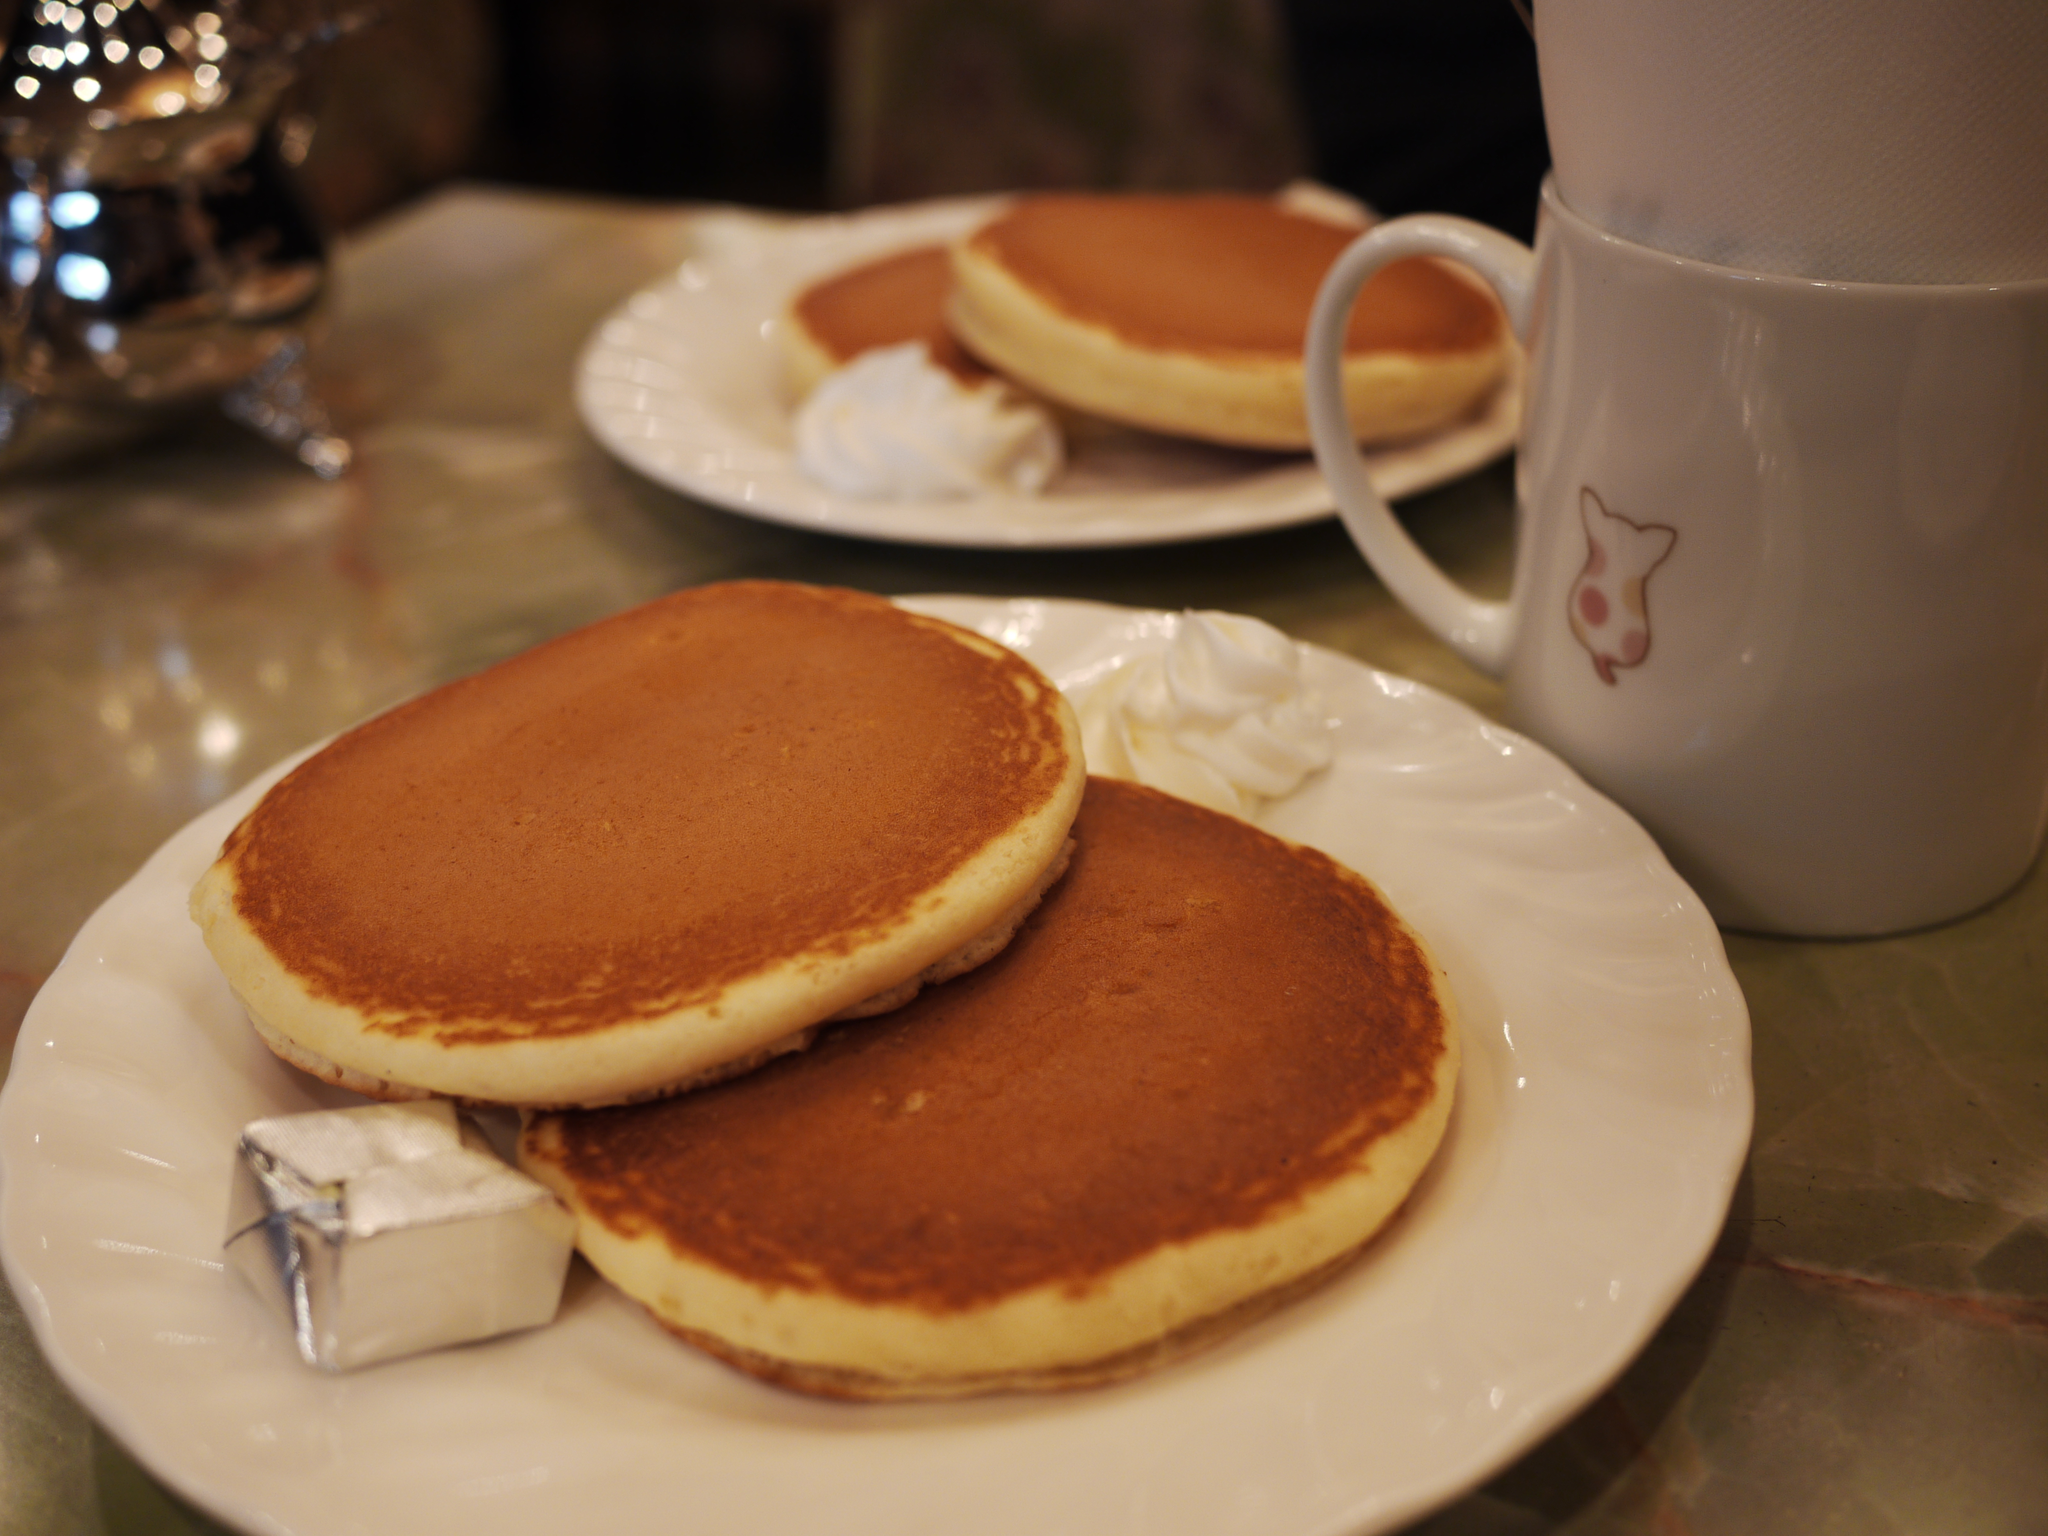How would you summarize this image in a sentence or two? In this picture we can see a table. On the table we can see the cups, plates which contains desserts and also we can see some other object. At the top the image is dark. 